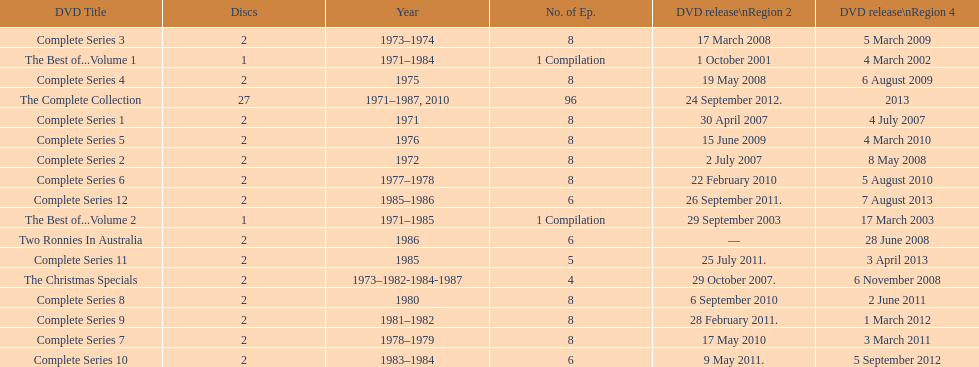What is the combined total of all discs presented in the table? 57. 